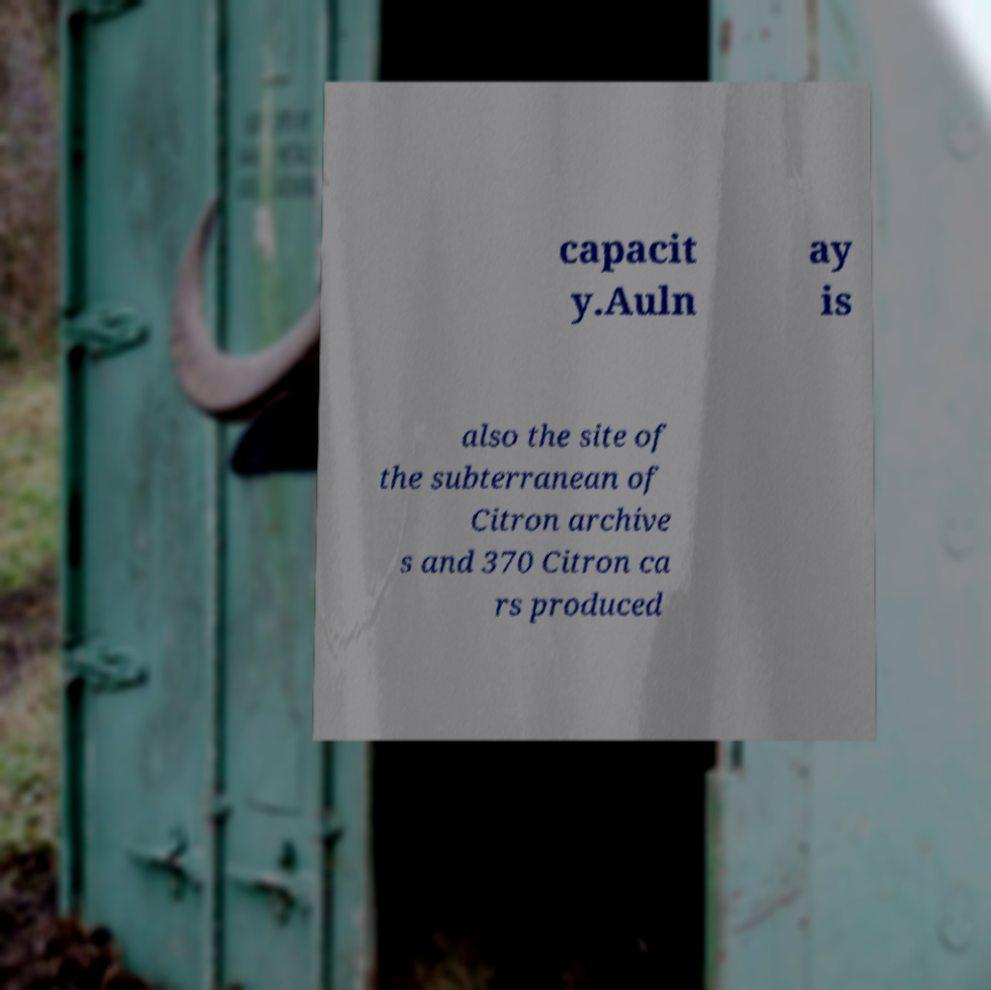Can you read and provide the text displayed in the image?This photo seems to have some interesting text. Can you extract and type it out for me? capacit y.Auln ay is also the site of the subterranean of Citron archive s and 370 Citron ca rs produced 